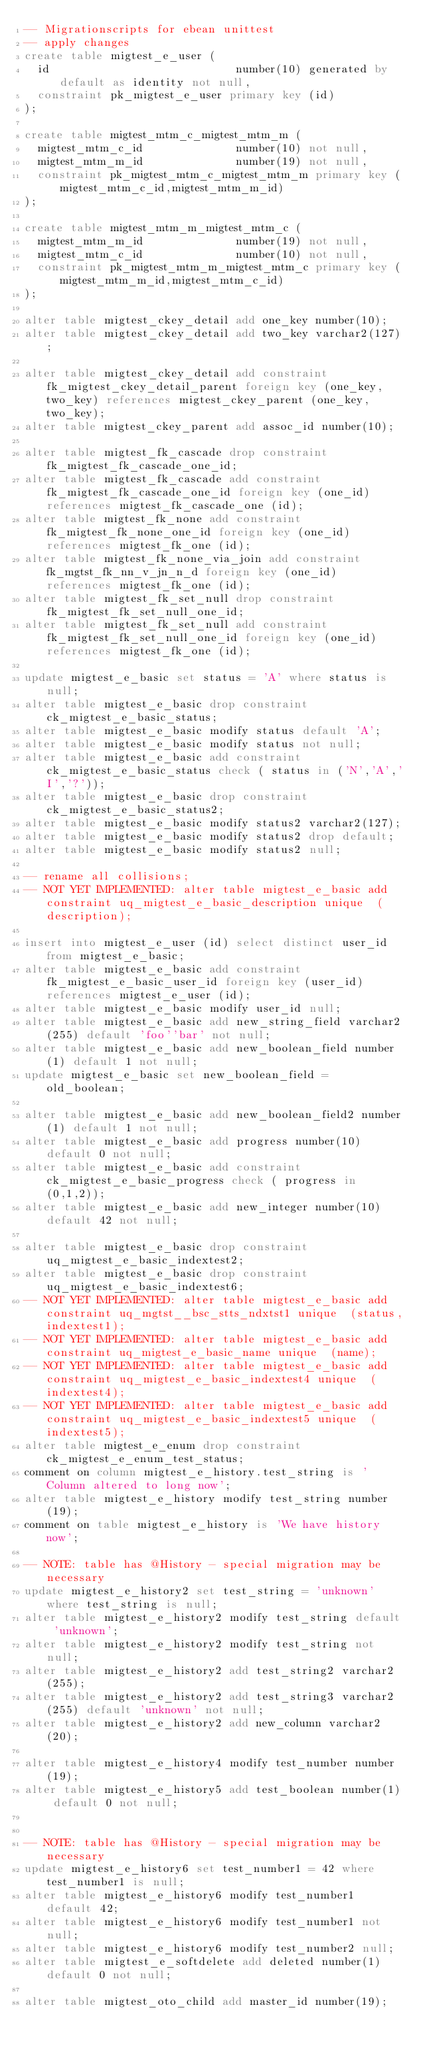<code> <loc_0><loc_0><loc_500><loc_500><_SQL_>-- Migrationscripts for ebean unittest
-- apply changes
create table migtest_e_user (
  id                            number(10) generated by default as identity not null,
  constraint pk_migtest_e_user primary key (id)
);

create table migtest_mtm_c_migtest_mtm_m (
  migtest_mtm_c_id              number(10) not null,
  migtest_mtm_m_id              number(19) not null,
  constraint pk_migtest_mtm_c_migtest_mtm_m primary key (migtest_mtm_c_id,migtest_mtm_m_id)
);

create table migtest_mtm_m_migtest_mtm_c (
  migtest_mtm_m_id              number(19) not null,
  migtest_mtm_c_id              number(10) not null,
  constraint pk_migtest_mtm_m_migtest_mtm_c primary key (migtest_mtm_m_id,migtest_mtm_c_id)
);

alter table migtest_ckey_detail add one_key number(10);
alter table migtest_ckey_detail add two_key varchar2(127);

alter table migtest_ckey_detail add constraint fk_migtest_ckey_detail_parent foreign key (one_key,two_key) references migtest_ckey_parent (one_key,two_key);
alter table migtest_ckey_parent add assoc_id number(10);

alter table migtest_fk_cascade drop constraint fk_migtest_fk_cascade_one_id;
alter table migtest_fk_cascade add constraint fk_migtest_fk_cascade_one_id foreign key (one_id) references migtest_fk_cascade_one (id);
alter table migtest_fk_none add constraint fk_migtest_fk_none_one_id foreign key (one_id) references migtest_fk_one (id);
alter table migtest_fk_none_via_join add constraint fk_mgtst_fk_nn_v_jn_n_d foreign key (one_id) references migtest_fk_one (id);
alter table migtest_fk_set_null drop constraint fk_migtest_fk_set_null_one_id;
alter table migtest_fk_set_null add constraint fk_migtest_fk_set_null_one_id foreign key (one_id) references migtest_fk_one (id);

update migtest_e_basic set status = 'A' where status is null;
alter table migtest_e_basic drop constraint ck_migtest_e_basic_status;
alter table migtest_e_basic modify status default 'A';
alter table migtest_e_basic modify status not null;
alter table migtest_e_basic add constraint ck_migtest_e_basic_status check ( status in ('N','A','I','?'));
alter table migtest_e_basic drop constraint ck_migtest_e_basic_status2;
alter table migtest_e_basic modify status2 varchar2(127);
alter table migtest_e_basic modify status2 drop default;
alter table migtest_e_basic modify status2 null;

-- rename all collisions;
-- NOT YET IMPLEMENTED: alter table migtest_e_basic add constraint uq_migtest_e_basic_description unique  (description);

insert into migtest_e_user (id) select distinct user_id from migtest_e_basic;
alter table migtest_e_basic add constraint fk_migtest_e_basic_user_id foreign key (user_id) references migtest_e_user (id);
alter table migtest_e_basic modify user_id null;
alter table migtest_e_basic add new_string_field varchar2(255) default 'foo''bar' not null;
alter table migtest_e_basic add new_boolean_field number(1) default 1 not null;
update migtest_e_basic set new_boolean_field = old_boolean;

alter table migtest_e_basic add new_boolean_field2 number(1) default 1 not null;
alter table migtest_e_basic add progress number(10) default 0 not null;
alter table migtest_e_basic add constraint ck_migtest_e_basic_progress check ( progress in (0,1,2));
alter table migtest_e_basic add new_integer number(10) default 42 not null;

alter table migtest_e_basic drop constraint uq_migtest_e_basic_indextest2;
alter table migtest_e_basic drop constraint uq_migtest_e_basic_indextest6;
-- NOT YET IMPLEMENTED: alter table migtest_e_basic add constraint uq_mgtst__bsc_stts_ndxtst1 unique  (status,indextest1);
-- NOT YET IMPLEMENTED: alter table migtest_e_basic add constraint uq_migtest_e_basic_name unique  (name);
-- NOT YET IMPLEMENTED: alter table migtest_e_basic add constraint uq_migtest_e_basic_indextest4 unique  (indextest4);
-- NOT YET IMPLEMENTED: alter table migtest_e_basic add constraint uq_migtest_e_basic_indextest5 unique  (indextest5);
alter table migtest_e_enum drop constraint ck_migtest_e_enum_test_status;
comment on column migtest_e_history.test_string is 'Column altered to long now';
alter table migtest_e_history modify test_string number(19);
comment on table migtest_e_history is 'We have history now';

-- NOTE: table has @History - special migration may be necessary
update migtest_e_history2 set test_string = 'unknown' where test_string is null;
alter table migtest_e_history2 modify test_string default 'unknown';
alter table migtest_e_history2 modify test_string not null;
alter table migtest_e_history2 add test_string2 varchar2(255);
alter table migtest_e_history2 add test_string3 varchar2(255) default 'unknown' not null;
alter table migtest_e_history2 add new_column varchar2(20);

alter table migtest_e_history4 modify test_number number(19);
alter table migtest_e_history5 add test_boolean number(1) default 0 not null;


-- NOTE: table has @History - special migration may be necessary
update migtest_e_history6 set test_number1 = 42 where test_number1 is null;
alter table migtest_e_history6 modify test_number1 default 42;
alter table migtest_e_history6 modify test_number1 not null;
alter table migtest_e_history6 modify test_number2 null;
alter table migtest_e_softdelete add deleted number(1) default 0 not null;

alter table migtest_oto_child add master_id number(19);
</code> 